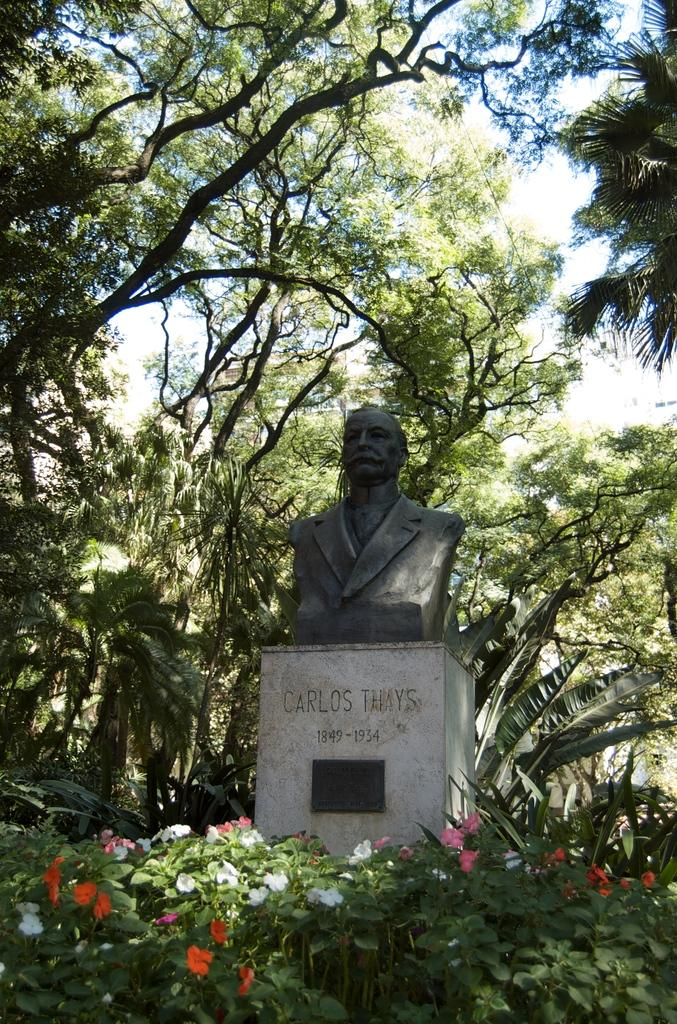What is the main subject in the image? There is a statue in the image. What is the statue placed on? The statue is on an object with some text. What type of vegetation can be seen in the image? There are plants and trees in the image. What is visible in the background of the image? The sky is visible in the image. What type of rail can be seen in the image? There is no rail present in the image. What flavor of soda is being served in the image? There is no soda present in the image. 